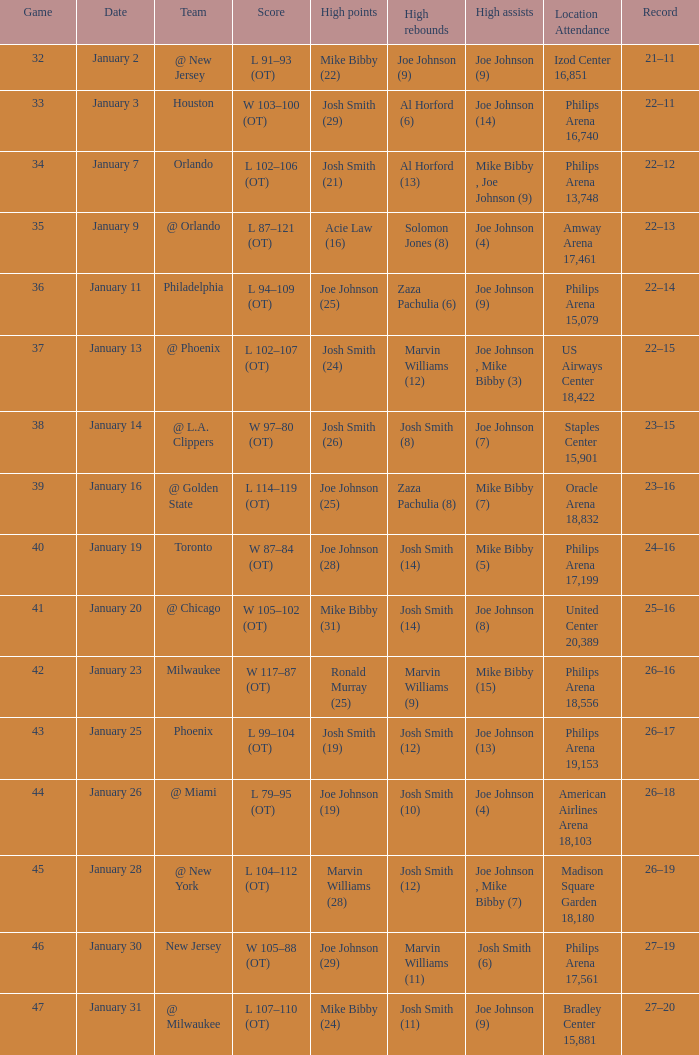What was the score following game 37? 22–15. Give me the full table as a dictionary. {'header': ['Game', 'Date', 'Team', 'Score', 'High points', 'High rebounds', 'High assists', 'Location Attendance', 'Record'], 'rows': [['32', 'January 2', '@ New Jersey', 'L 91–93 (OT)', 'Mike Bibby (22)', 'Joe Johnson (9)', 'Joe Johnson (9)', 'Izod Center 16,851', '21–11'], ['33', 'January 3', 'Houston', 'W 103–100 (OT)', 'Josh Smith (29)', 'Al Horford (6)', 'Joe Johnson (14)', 'Philips Arena 16,740', '22–11'], ['34', 'January 7', 'Orlando', 'L 102–106 (OT)', 'Josh Smith (21)', 'Al Horford (13)', 'Mike Bibby , Joe Johnson (9)', 'Philips Arena 13,748', '22–12'], ['35', 'January 9', '@ Orlando', 'L 87–121 (OT)', 'Acie Law (16)', 'Solomon Jones (8)', 'Joe Johnson (4)', 'Amway Arena 17,461', '22–13'], ['36', 'January 11', 'Philadelphia', 'L 94–109 (OT)', 'Joe Johnson (25)', 'Zaza Pachulia (6)', 'Joe Johnson (9)', 'Philips Arena 15,079', '22–14'], ['37', 'January 13', '@ Phoenix', 'L 102–107 (OT)', 'Josh Smith (24)', 'Marvin Williams (12)', 'Joe Johnson , Mike Bibby (3)', 'US Airways Center 18,422', '22–15'], ['38', 'January 14', '@ L.A. Clippers', 'W 97–80 (OT)', 'Josh Smith (26)', 'Josh Smith (8)', 'Joe Johnson (7)', 'Staples Center 15,901', '23–15'], ['39', 'January 16', '@ Golden State', 'L 114–119 (OT)', 'Joe Johnson (25)', 'Zaza Pachulia (8)', 'Mike Bibby (7)', 'Oracle Arena 18,832', '23–16'], ['40', 'January 19', 'Toronto', 'W 87–84 (OT)', 'Joe Johnson (28)', 'Josh Smith (14)', 'Mike Bibby (5)', 'Philips Arena 17,199', '24–16'], ['41', 'January 20', '@ Chicago', 'W 105–102 (OT)', 'Mike Bibby (31)', 'Josh Smith (14)', 'Joe Johnson (8)', 'United Center 20,389', '25–16'], ['42', 'January 23', 'Milwaukee', 'W 117–87 (OT)', 'Ronald Murray (25)', 'Marvin Williams (9)', 'Mike Bibby (15)', 'Philips Arena 18,556', '26–16'], ['43', 'January 25', 'Phoenix', 'L 99–104 (OT)', 'Josh Smith (19)', 'Josh Smith (12)', 'Joe Johnson (13)', 'Philips Arena 19,153', '26–17'], ['44', 'January 26', '@ Miami', 'L 79–95 (OT)', 'Joe Johnson (19)', 'Josh Smith (10)', 'Joe Johnson (4)', 'American Airlines Arena 18,103', '26–18'], ['45', 'January 28', '@ New York', 'L 104–112 (OT)', 'Marvin Williams (28)', 'Josh Smith (12)', 'Joe Johnson , Mike Bibby (7)', 'Madison Square Garden 18,180', '26–19'], ['46', 'January 30', 'New Jersey', 'W 105–88 (OT)', 'Joe Johnson (29)', 'Marvin Williams (11)', 'Josh Smith (6)', 'Philips Arena 17,561', '27–19'], ['47', 'January 31', '@ Milwaukee', 'L 107–110 (OT)', 'Mike Bibby (24)', 'Josh Smith (11)', 'Joe Johnson (9)', 'Bradley Center 15,881', '27–20']]} 